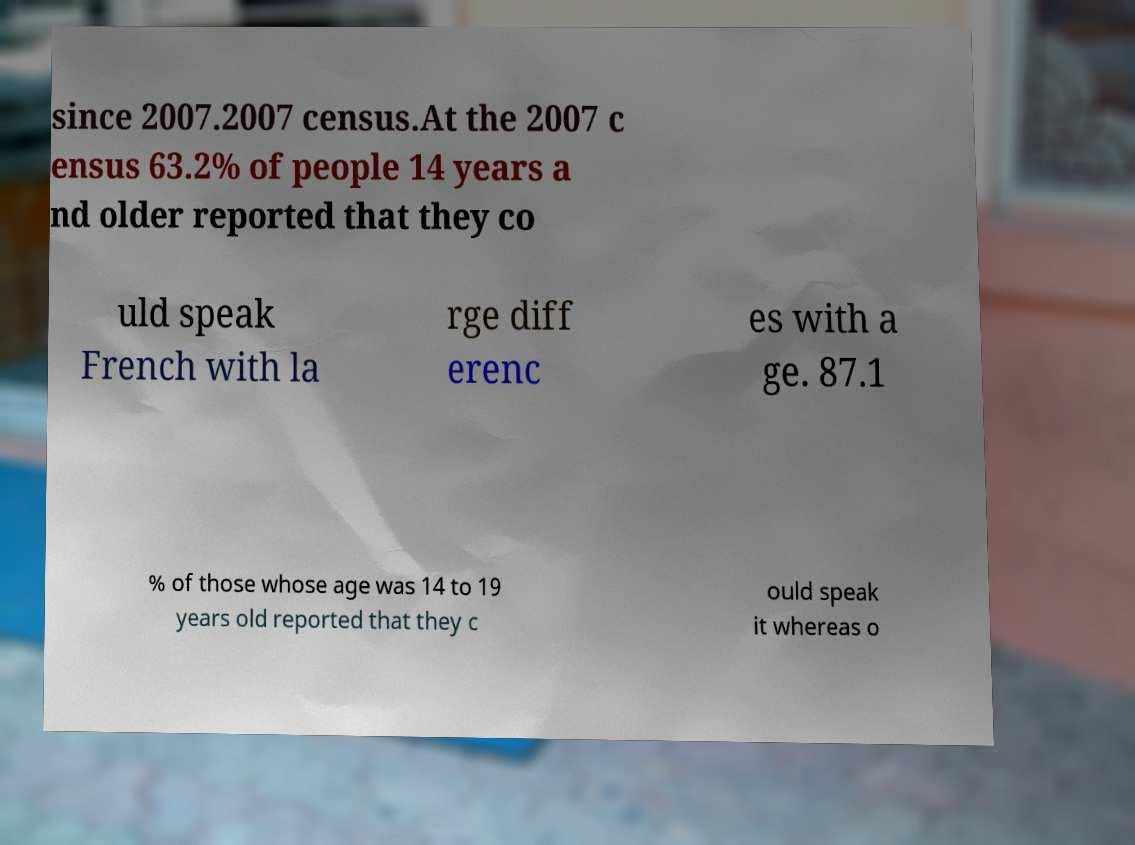Could you assist in decoding the text presented in this image and type it out clearly? since 2007.2007 census.At the 2007 c ensus 63.2% of people 14 years a nd older reported that they co uld speak French with la rge diff erenc es with a ge. 87.1 % of those whose age was 14 to 19 years old reported that they c ould speak it whereas o 